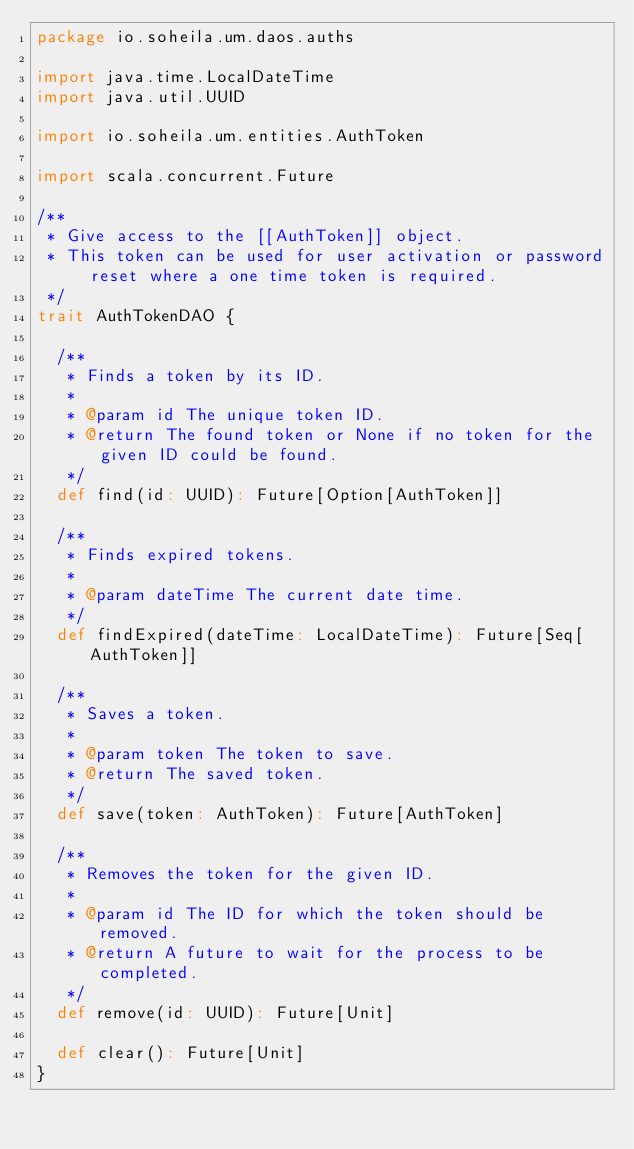Convert code to text. <code><loc_0><loc_0><loc_500><loc_500><_Scala_>package io.soheila.um.daos.auths

import java.time.LocalDateTime
import java.util.UUID

import io.soheila.um.entities.AuthToken

import scala.concurrent.Future

/**
 * Give access to the [[AuthToken]] object.
 * This token can be used for user activation or password reset where a one time token is required.
 */
trait AuthTokenDAO {

  /**
   * Finds a token by its ID.
   *
   * @param id The unique token ID.
   * @return The found token or None if no token for the given ID could be found.
   */
  def find(id: UUID): Future[Option[AuthToken]]

  /**
   * Finds expired tokens.
   *
   * @param dateTime The current date time.
   */
  def findExpired(dateTime: LocalDateTime): Future[Seq[AuthToken]]

  /**
   * Saves a token.
   *
   * @param token The token to save.
   * @return The saved token.
   */
  def save(token: AuthToken): Future[AuthToken]

  /**
   * Removes the token for the given ID.
   *
   * @param id The ID for which the token should be removed.
   * @return A future to wait for the process to be completed.
   */
  def remove(id: UUID): Future[Unit]

  def clear(): Future[Unit]
}
</code> 